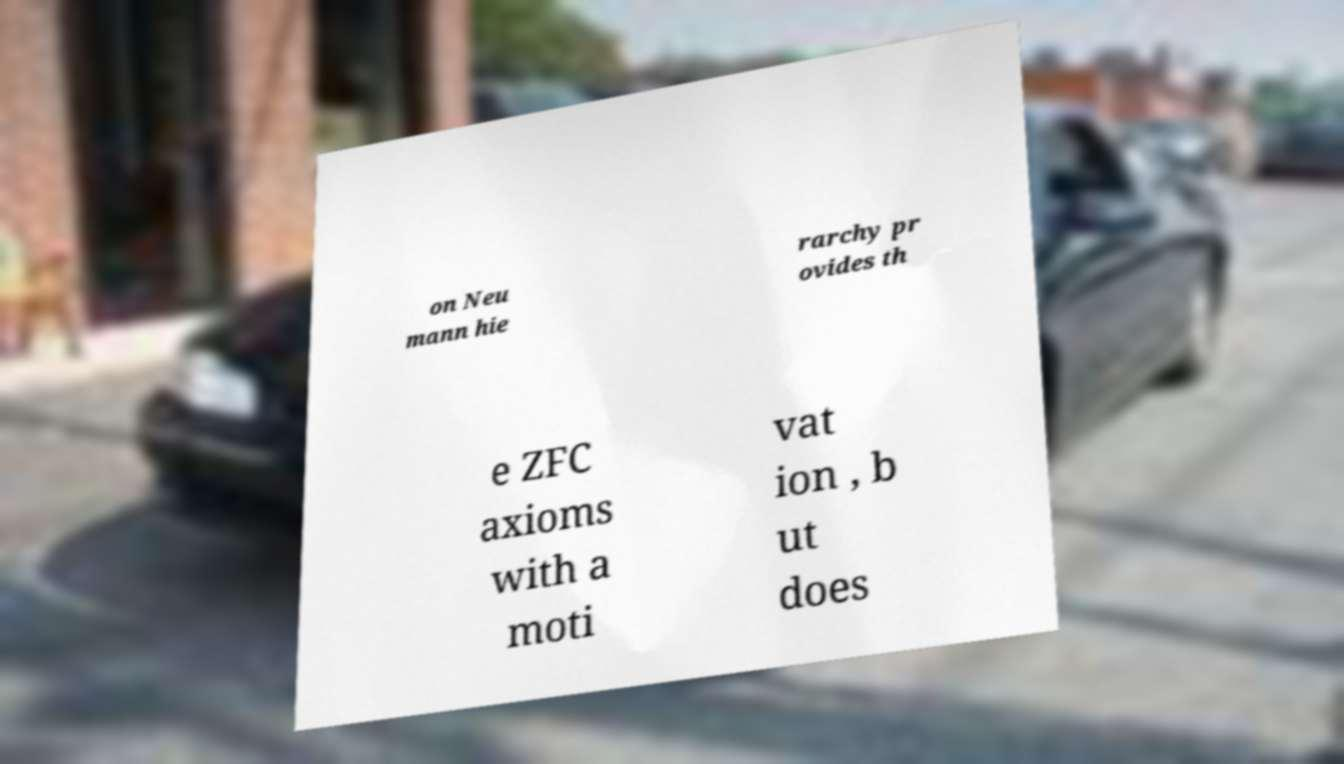There's text embedded in this image that I need extracted. Can you transcribe it verbatim? on Neu mann hie rarchy pr ovides th e ZFC axioms with a moti vat ion , b ut does 